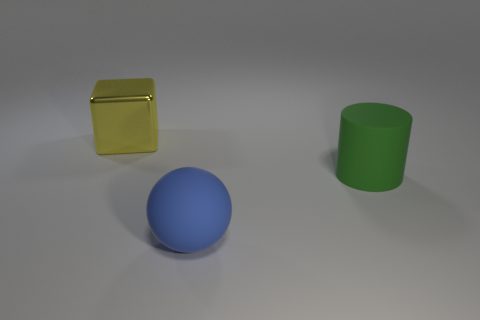There is a block that is the same size as the cylinder; what is it made of?
Provide a succinct answer. Metal. There is a object that is left of the green thing and right of the shiny block; what is its size?
Offer a very short reply. Large. What number of things are big matte objects or objects to the left of the blue matte object?
Provide a succinct answer. 3. What is the shape of the large green thing?
Make the answer very short. Cylinder. The big thing behind the rubber thing on the right side of the blue rubber ball is what shape?
Ensure brevity in your answer.  Cube. There is a large thing that is made of the same material as the large blue sphere; what color is it?
Offer a very short reply. Green. Are there any other things that have the same size as the yellow cube?
Your response must be concise. Yes. Do the large object that is to the right of the blue sphere and the object left of the big blue sphere have the same color?
Provide a short and direct response. No. Is the number of large green cylinders that are in front of the big green matte thing greater than the number of green rubber things that are left of the large yellow shiny cube?
Provide a succinct answer. No. Is there anything else that has the same shape as the green rubber object?
Your answer should be very brief. No. 